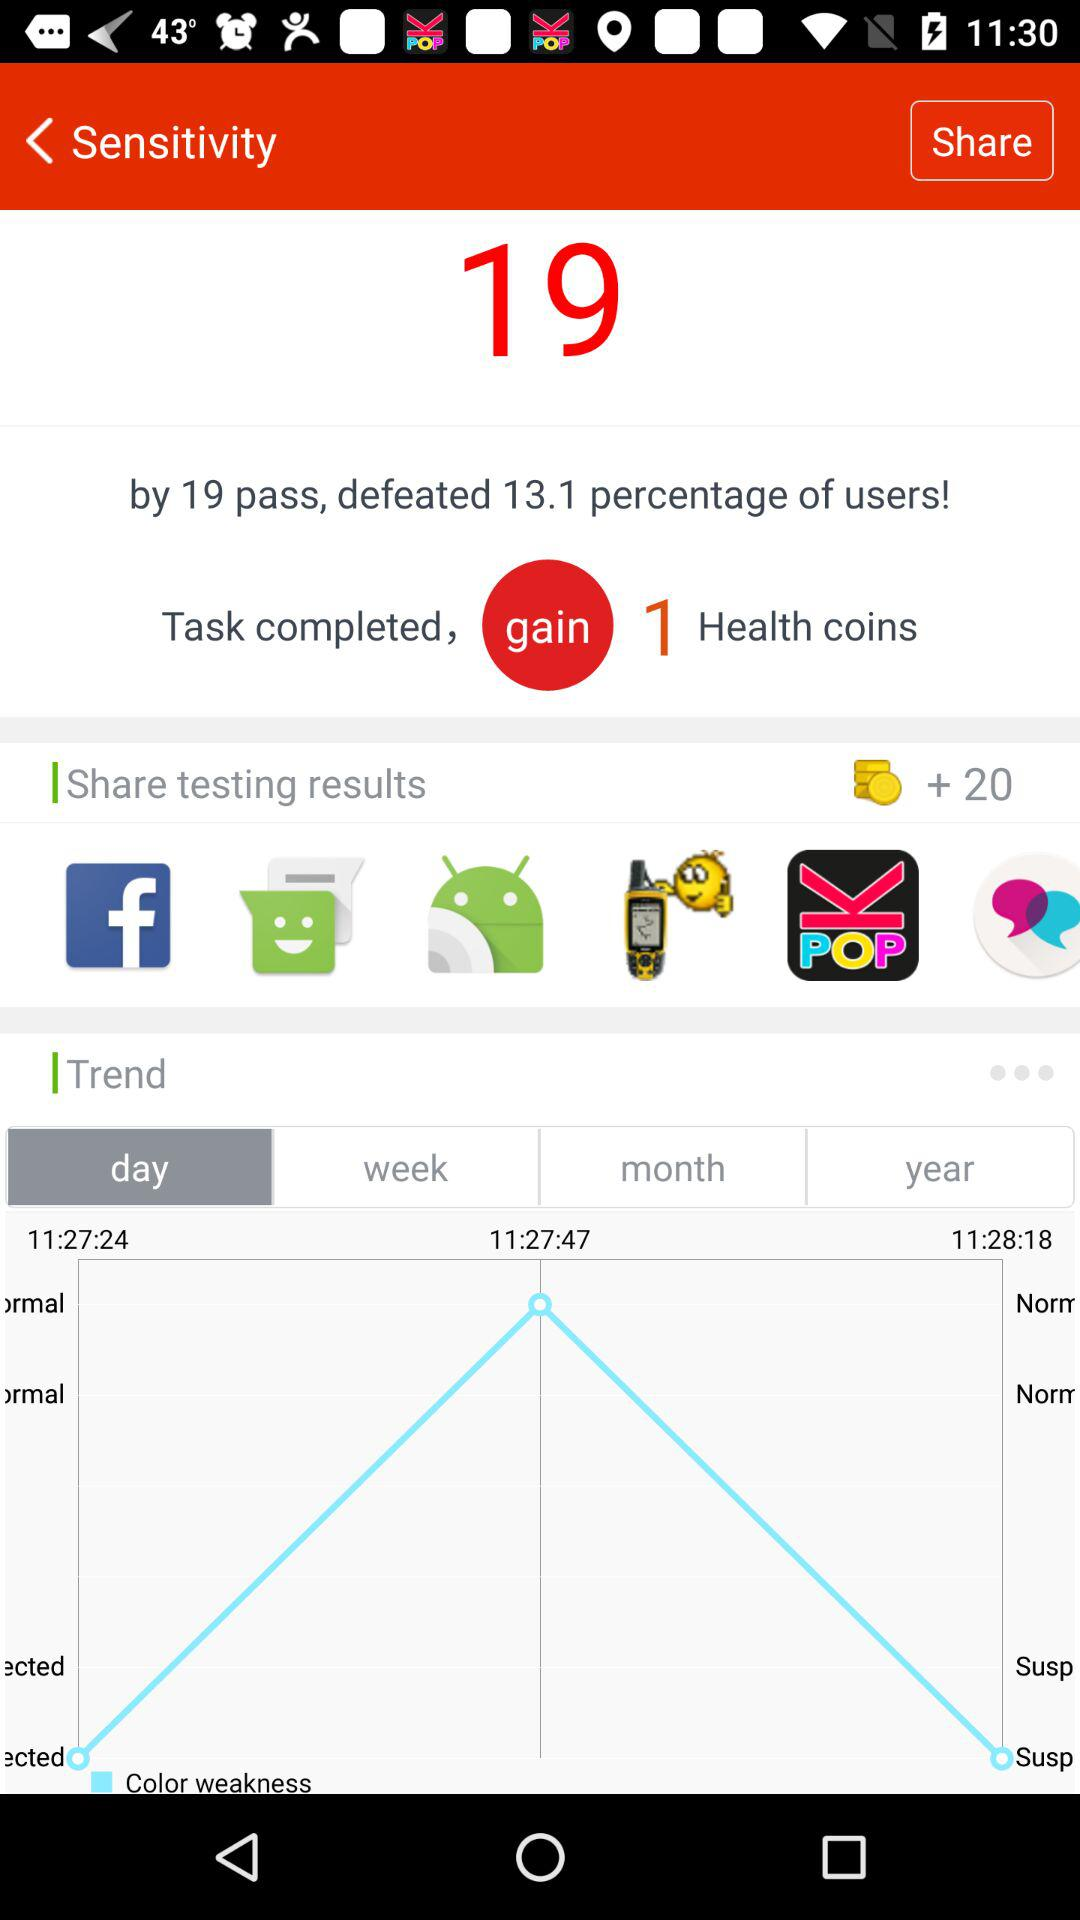How many more percentage points did the user beat the average by?
Answer the question using a single word or phrase. 13.1 